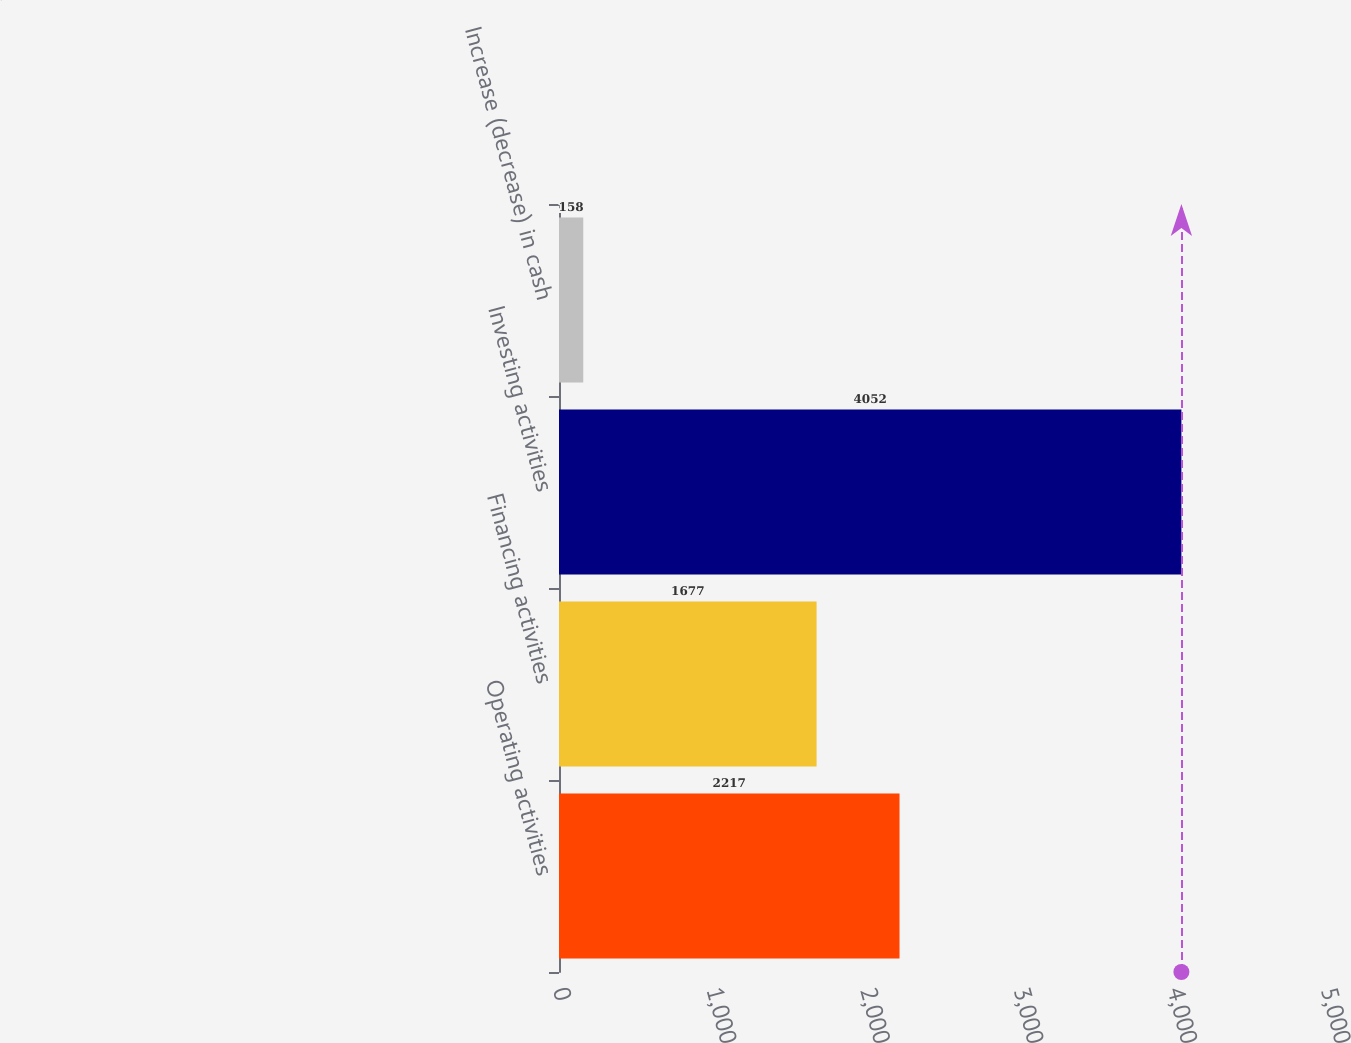Convert chart to OTSL. <chart><loc_0><loc_0><loc_500><loc_500><bar_chart><fcel>Operating activities<fcel>Financing activities<fcel>Investing activities<fcel>Increase (decrease) in cash<nl><fcel>2217<fcel>1677<fcel>4052<fcel>158<nl></chart> 